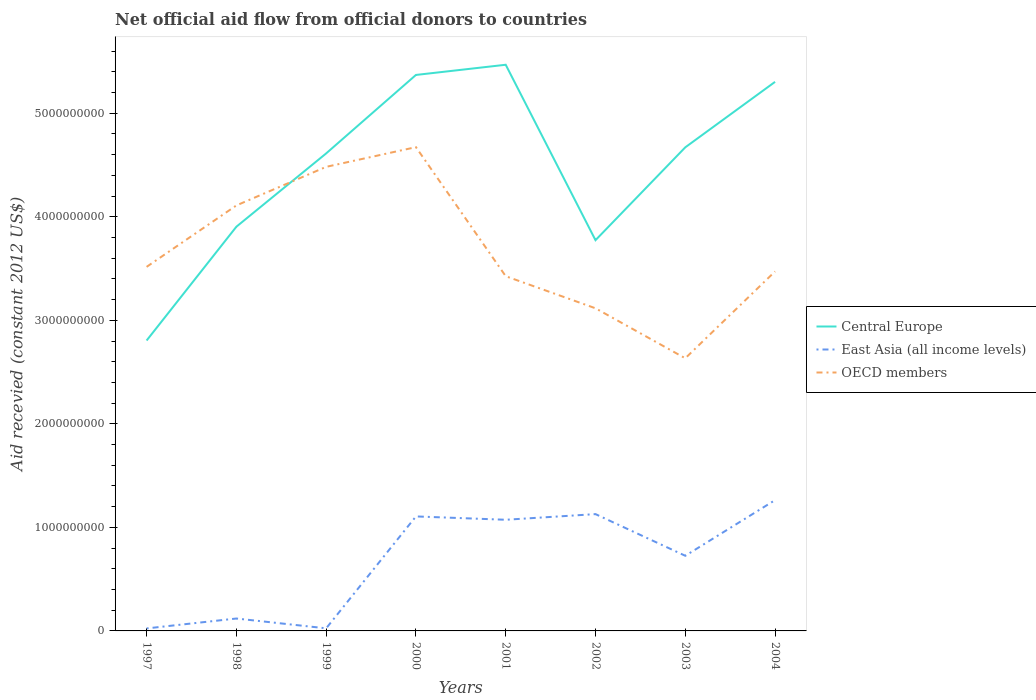Is the number of lines equal to the number of legend labels?
Your answer should be very brief. Yes. Across all years, what is the maximum total aid received in East Asia (all income levels)?
Provide a short and direct response. 2.41e+07. What is the total total aid received in East Asia (all income levels) in the graph?
Offer a very short reply. -1.90e+08. What is the difference between the highest and the second highest total aid received in East Asia (all income levels)?
Make the answer very short. 1.24e+09. Is the total aid received in Central Europe strictly greater than the total aid received in East Asia (all income levels) over the years?
Offer a very short reply. No. How many years are there in the graph?
Ensure brevity in your answer.  8. Does the graph contain any zero values?
Provide a succinct answer. No. How many legend labels are there?
Give a very brief answer. 3. What is the title of the graph?
Provide a succinct answer. Net official aid flow from official donors to countries. What is the label or title of the Y-axis?
Your response must be concise. Aid recevied (constant 2012 US$). What is the Aid recevied (constant 2012 US$) in Central Europe in 1997?
Ensure brevity in your answer.  2.81e+09. What is the Aid recevied (constant 2012 US$) in East Asia (all income levels) in 1997?
Your response must be concise. 2.41e+07. What is the Aid recevied (constant 2012 US$) of OECD members in 1997?
Offer a very short reply. 3.52e+09. What is the Aid recevied (constant 2012 US$) of Central Europe in 1998?
Your answer should be very brief. 3.90e+09. What is the Aid recevied (constant 2012 US$) of East Asia (all income levels) in 1998?
Make the answer very short. 1.20e+08. What is the Aid recevied (constant 2012 US$) of OECD members in 1998?
Offer a terse response. 4.11e+09. What is the Aid recevied (constant 2012 US$) of Central Europe in 1999?
Offer a terse response. 4.61e+09. What is the Aid recevied (constant 2012 US$) in East Asia (all income levels) in 1999?
Keep it short and to the point. 2.50e+07. What is the Aid recevied (constant 2012 US$) of OECD members in 1999?
Provide a short and direct response. 4.48e+09. What is the Aid recevied (constant 2012 US$) in Central Europe in 2000?
Keep it short and to the point. 5.37e+09. What is the Aid recevied (constant 2012 US$) of East Asia (all income levels) in 2000?
Offer a terse response. 1.11e+09. What is the Aid recevied (constant 2012 US$) of OECD members in 2000?
Give a very brief answer. 4.67e+09. What is the Aid recevied (constant 2012 US$) in Central Europe in 2001?
Make the answer very short. 5.47e+09. What is the Aid recevied (constant 2012 US$) of East Asia (all income levels) in 2001?
Your response must be concise. 1.07e+09. What is the Aid recevied (constant 2012 US$) of OECD members in 2001?
Ensure brevity in your answer.  3.43e+09. What is the Aid recevied (constant 2012 US$) in Central Europe in 2002?
Your answer should be compact. 3.77e+09. What is the Aid recevied (constant 2012 US$) of East Asia (all income levels) in 2002?
Your answer should be compact. 1.13e+09. What is the Aid recevied (constant 2012 US$) of OECD members in 2002?
Your response must be concise. 3.12e+09. What is the Aid recevied (constant 2012 US$) in Central Europe in 2003?
Ensure brevity in your answer.  4.67e+09. What is the Aid recevied (constant 2012 US$) in East Asia (all income levels) in 2003?
Your answer should be compact. 7.26e+08. What is the Aid recevied (constant 2012 US$) in OECD members in 2003?
Make the answer very short. 2.63e+09. What is the Aid recevied (constant 2012 US$) of Central Europe in 2004?
Your answer should be compact. 5.30e+09. What is the Aid recevied (constant 2012 US$) in East Asia (all income levels) in 2004?
Provide a short and direct response. 1.26e+09. What is the Aid recevied (constant 2012 US$) of OECD members in 2004?
Your answer should be very brief. 3.47e+09. Across all years, what is the maximum Aid recevied (constant 2012 US$) in Central Europe?
Give a very brief answer. 5.47e+09. Across all years, what is the maximum Aid recevied (constant 2012 US$) of East Asia (all income levels)?
Keep it short and to the point. 1.26e+09. Across all years, what is the maximum Aid recevied (constant 2012 US$) in OECD members?
Offer a very short reply. 4.67e+09. Across all years, what is the minimum Aid recevied (constant 2012 US$) in Central Europe?
Give a very brief answer. 2.81e+09. Across all years, what is the minimum Aid recevied (constant 2012 US$) of East Asia (all income levels)?
Provide a succinct answer. 2.41e+07. Across all years, what is the minimum Aid recevied (constant 2012 US$) in OECD members?
Your answer should be compact. 2.63e+09. What is the total Aid recevied (constant 2012 US$) of Central Europe in the graph?
Your answer should be very brief. 3.59e+1. What is the total Aid recevied (constant 2012 US$) of East Asia (all income levels) in the graph?
Your answer should be very brief. 5.47e+09. What is the total Aid recevied (constant 2012 US$) in OECD members in the graph?
Offer a very short reply. 2.94e+1. What is the difference between the Aid recevied (constant 2012 US$) of Central Europe in 1997 and that in 1998?
Provide a succinct answer. -1.10e+09. What is the difference between the Aid recevied (constant 2012 US$) in East Asia (all income levels) in 1997 and that in 1998?
Keep it short and to the point. -9.57e+07. What is the difference between the Aid recevied (constant 2012 US$) in OECD members in 1997 and that in 1998?
Provide a succinct answer. -5.93e+08. What is the difference between the Aid recevied (constant 2012 US$) in Central Europe in 1997 and that in 1999?
Your answer should be compact. -1.81e+09. What is the difference between the Aid recevied (constant 2012 US$) in East Asia (all income levels) in 1997 and that in 1999?
Offer a terse response. -9.50e+05. What is the difference between the Aid recevied (constant 2012 US$) of OECD members in 1997 and that in 1999?
Keep it short and to the point. -9.66e+08. What is the difference between the Aid recevied (constant 2012 US$) of Central Europe in 1997 and that in 2000?
Keep it short and to the point. -2.57e+09. What is the difference between the Aid recevied (constant 2012 US$) in East Asia (all income levels) in 1997 and that in 2000?
Ensure brevity in your answer.  -1.08e+09. What is the difference between the Aid recevied (constant 2012 US$) in OECD members in 1997 and that in 2000?
Give a very brief answer. -1.16e+09. What is the difference between the Aid recevied (constant 2012 US$) in Central Europe in 1997 and that in 2001?
Offer a terse response. -2.66e+09. What is the difference between the Aid recevied (constant 2012 US$) in East Asia (all income levels) in 1997 and that in 2001?
Give a very brief answer. -1.05e+09. What is the difference between the Aid recevied (constant 2012 US$) of OECD members in 1997 and that in 2001?
Ensure brevity in your answer.  9.02e+07. What is the difference between the Aid recevied (constant 2012 US$) in Central Europe in 1997 and that in 2002?
Give a very brief answer. -9.69e+08. What is the difference between the Aid recevied (constant 2012 US$) of East Asia (all income levels) in 1997 and that in 2002?
Give a very brief answer. -1.10e+09. What is the difference between the Aid recevied (constant 2012 US$) of OECD members in 1997 and that in 2002?
Your answer should be very brief. 4.00e+08. What is the difference between the Aid recevied (constant 2012 US$) in Central Europe in 1997 and that in 2003?
Give a very brief answer. -1.87e+09. What is the difference between the Aid recevied (constant 2012 US$) of East Asia (all income levels) in 1997 and that in 2003?
Make the answer very short. -7.02e+08. What is the difference between the Aid recevied (constant 2012 US$) in OECD members in 1997 and that in 2003?
Your answer should be compact. 8.83e+08. What is the difference between the Aid recevied (constant 2012 US$) of Central Europe in 1997 and that in 2004?
Offer a very short reply. -2.50e+09. What is the difference between the Aid recevied (constant 2012 US$) in East Asia (all income levels) in 1997 and that in 2004?
Give a very brief answer. -1.24e+09. What is the difference between the Aid recevied (constant 2012 US$) of OECD members in 1997 and that in 2004?
Provide a succinct answer. 4.42e+07. What is the difference between the Aid recevied (constant 2012 US$) in Central Europe in 1998 and that in 1999?
Your answer should be compact. -7.08e+08. What is the difference between the Aid recevied (constant 2012 US$) in East Asia (all income levels) in 1998 and that in 1999?
Offer a terse response. 9.48e+07. What is the difference between the Aid recevied (constant 2012 US$) of OECD members in 1998 and that in 1999?
Give a very brief answer. -3.73e+08. What is the difference between the Aid recevied (constant 2012 US$) in Central Europe in 1998 and that in 2000?
Provide a succinct answer. -1.47e+09. What is the difference between the Aid recevied (constant 2012 US$) in East Asia (all income levels) in 1998 and that in 2000?
Provide a succinct answer. -9.86e+08. What is the difference between the Aid recevied (constant 2012 US$) of OECD members in 1998 and that in 2000?
Ensure brevity in your answer.  -5.63e+08. What is the difference between the Aid recevied (constant 2012 US$) of Central Europe in 1998 and that in 2001?
Keep it short and to the point. -1.56e+09. What is the difference between the Aid recevied (constant 2012 US$) in East Asia (all income levels) in 1998 and that in 2001?
Keep it short and to the point. -9.54e+08. What is the difference between the Aid recevied (constant 2012 US$) in OECD members in 1998 and that in 2001?
Your response must be concise. 6.84e+08. What is the difference between the Aid recevied (constant 2012 US$) in Central Europe in 1998 and that in 2002?
Offer a very short reply. 1.30e+08. What is the difference between the Aid recevied (constant 2012 US$) of East Asia (all income levels) in 1998 and that in 2002?
Offer a very short reply. -1.01e+09. What is the difference between the Aid recevied (constant 2012 US$) of OECD members in 1998 and that in 2002?
Offer a terse response. 9.93e+08. What is the difference between the Aid recevied (constant 2012 US$) in Central Europe in 1998 and that in 2003?
Give a very brief answer. -7.67e+08. What is the difference between the Aid recevied (constant 2012 US$) of East Asia (all income levels) in 1998 and that in 2003?
Provide a short and direct response. -6.06e+08. What is the difference between the Aid recevied (constant 2012 US$) in OECD members in 1998 and that in 2003?
Keep it short and to the point. 1.48e+09. What is the difference between the Aid recevied (constant 2012 US$) of Central Europe in 1998 and that in 2004?
Your answer should be compact. -1.40e+09. What is the difference between the Aid recevied (constant 2012 US$) in East Asia (all income levels) in 1998 and that in 2004?
Provide a short and direct response. -1.14e+09. What is the difference between the Aid recevied (constant 2012 US$) of OECD members in 1998 and that in 2004?
Offer a very short reply. 6.38e+08. What is the difference between the Aid recevied (constant 2012 US$) in Central Europe in 1999 and that in 2000?
Provide a short and direct response. -7.58e+08. What is the difference between the Aid recevied (constant 2012 US$) of East Asia (all income levels) in 1999 and that in 2000?
Your response must be concise. -1.08e+09. What is the difference between the Aid recevied (constant 2012 US$) in OECD members in 1999 and that in 2000?
Your answer should be very brief. -1.90e+08. What is the difference between the Aid recevied (constant 2012 US$) in Central Europe in 1999 and that in 2001?
Make the answer very short. -8.56e+08. What is the difference between the Aid recevied (constant 2012 US$) of East Asia (all income levels) in 1999 and that in 2001?
Keep it short and to the point. -1.05e+09. What is the difference between the Aid recevied (constant 2012 US$) of OECD members in 1999 and that in 2001?
Offer a very short reply. 1.06e+09. What is the difference between the Aid recevied (constant 2012 US$) of Central Europe in 1999 and that in 2002?
Make the answer very short. 8.38e+08. What is the difference between the Aid recevied (constant 2012 US$) of East Asia (all income levels) in 1999 and that in 2002?
Give a very brief answer. -1.10e+09. What is the difference between the Aid recevied (constant 2012 US$) of OECD members in 1999 and that in 2002?
Provide a succinct answer. 1.37e+09. What is the difference between the Aid recevied (constant 2012 US$) of Central Europe in 1999 and that in 2003?
Your response must be concise. -5.87e+07. What is the difference between the Aid recevied (constant 2012 US$) in East Asia (all income levels) in 1999 and that in 2003?
Give a very brief answer. -7.01e+08. What is the difference between the Aid recevied (constant 2012 US$) of OECD members in 1999 and that in 2003?
Make the answer very short. 1.85e+09. What is the difference between the Aid recevied (constant 2012 US$) in Central Europe in 1999 and that in 2004?
Provide a short and direct response. -6.91e+08. What is the difference between the Aid recevied (constant 2012 US$) in East Asia (all income levels) in 1999 and that in 2004?
Provide a short and direct response. -1.24e+09. What is the difference between the Aid recevied (constant 2012 US$) in OECD members in 1999 and that in 2004?
Provide a succinct answer. 1.01e+09. What is the difference between the Aid recevied (constant 2012 US$) in Central Europe in 2000 and that in 2001?
Your answer should be very brief. -9.83e+07. What is the difference between the Aid recevied (constant 2012 US$) in East Asia (all income levels) in 2000 and that in 2001?
Make the answer very short. 3.23e+07. What is the difference between the Aid recevied (constant 2012 US$) of OECD members in 2000 and that in 2001?
Ensure brevity in your answer.  1.25e+09. What is the difference between the Aid recevied (constant 2012 US$) in Central Europe in 2000 and that in 2002?
Provide a short and direct response. 1.60e+09. What is the difference between the Aid recevied (constant 2012 US$) in East Asia (all income levels) in 2000 and that in 2002?
Your answer should be compact. -2.23e+07. What is the difference between the Aid recevied (constant 2012 US$) of OECD members in 2000 and that in 2002?
Make the answer very short. 1.56e+09. What is the difference between the Aid recevied (constant 2012 US$) in Central Europe in 2000 and that in 2003?
Provide a succinct answer. 6.99e+08. What is the difference between the Aid recevied (constant 2012 US$) of East Asia (all income levels) in 2000 and that in 2003?
Keep it short and to the point. 3.80e+08. What is the difference between the Aid recevied (constant 2012 US$) in OECD members in 2000 and that in 2003?
Give a very brief answer. 2.04e+09. What is the difference between the Aid recevied (constant 2012 US$) of Central Europe in 2000 and that in 2004?
Your answer should be compact. 6.68e+07. What is the difference between the Aid recevied (constant 2012 US$) of East Asia (all income levels) in 2000 and that in 2004?
Your answer should be very brief. -1.57e+08. What is the difference between the Aid recevied (constant 2012 US$) in OECD members in 2000 and that in 2004?
Your answer should be very brief. 1.20e+09. What is the difference between the Aid recevied (constant 2012 US$) of Central Europe in 2001 and that in 2002?
Your response must be concise. 1.69e+09. What is the difference between the Aid recevied (constant 2012 US$) of East Asia (all income levels) in 2001 and that in 2002?
Give a very brief answer. -5.46e+07. What is the difference between the Aid recevied (constant 2012 US$) in OECD members in 2001 and that in 2002?
Provide a succinct answer. 3.10e+08. What is the difference between the Aid recevied (constant 2012 US$) of Central Europe in 2001 and that in 2003?
Ensure brevity in your answer.  7.98e+08. What is the difference between the Aid recevied (constant 2012 US$) of East Asia (all income levels) in 2001 and that in 2003?
Provide a succinct answer. 3.48e+08. What is the difference between the Aid recevied (constant 2012 US$) in OECD members in 2001 and that in 2003?
Provide a succinct answer. 7.93e+08. What is the difference between the Aid recevied (constant 2012 US$) in Central Europe in 2001 and that in 2004?
Offer a terse response. 1.65e+08. What is the difference between the Aid recevied (constant 2012 US$) in East Asia (all income levels) in 2001 and that in 2004?
Provide a succinct answer. -1.90e+08. What is the difference between the Aid recevied (constant 2012 US$) in OECD members in 2001 and that in 2004?
Provide a short and direct response. -4.60e+07. What is the difference between the Aid recevied (constant 2012 US$) in Central Europe in 2002 and that in 2003?
Your answer should be compact. -8.97e+08. What is the difference between the Aid recevied (constant 2012 US$) in East Asia (all income levels) in 2002 and that in 2003?
Provide a succinct answer. 4.02e+08. What is the difference between the Aid recevied (constant 2012 US$) in OECD members in 2002 and that in 2003?
Offer a terse response. 4.83e+08. What is the difference between the Aid recevied (constant 2012 US$) of Central Europe in 2002 and that in 2004?
Your answer should be compact. -1.53e+09. What is the difference between the Aid recevied (constant 2012 US$) of East Asia (all income levels) in 2002 and that in 2004?
Offer a very short reply. -1.35e+08. What is the difference between the Aid recevied (constant 2012 US$) in OECD members in 2002 and that in 2004?
Give a very brief answer. -3.56e+08. What is the difference between the Aid recevied (constant 2012 US$) of Central Europe in 2003 and that in 2004?
Make the answer very short. -6.32e+08. What is the difference between the Aid recevied (constant 2012 US$) of East Asia (all income levels) in 2003 and that in 2004?
Offer a terse response. -5.38e+08. What is the difference between the Aid recevied (constant 2012 US$) of OECD members in 2003 and that in 2004?
Give a very brief answer. -8.39e+08. What is the difference between the Aid recevied (constant 2012 US$) in Central Europe in 1997 and the Aid recevied (constant 2012 US$) in East Asia (all income levels) in 1998?
Your answer should be very brief. 2.69e+09. What is the difference between the Aid recevied (constant 2012 US$) in Central Europe in 1997 and the Aid recevied (constant 2012 US$) in OECD members in 1998?
Offer a very short reply. -1.30e+09. What is the difference between the Aid recevied (constant 2012 US$) in East Asia (all income levels) in 1997 and the Aid recevied (constant 2012 US$) in OECD members in 1998?
Your answer should be very brief. -4.09e+09. What is the difference between the Aid recevied (constant 2012 US$) of Central Europe in 1997 and the Aid recevied (constant 2012 US$) of East Asia (all income levels) in 1999?
Keep it short and to the point. 2.78e+09. What is the difference between the Aid recevied (constant 2012 US$) in Central Europe in 1997 and the Aid recevied (constant 2012 US$) in OECD members in 1999?
Your answer should be compact. -1.68e+09. What is the difference between the Aid recevied (constant 2012 US$) in East Asia (all income levels) in 1997 and the Aid recevied (constant 2012 US$) in OECD members in 1999?
Offer a very short reply. -4.46e+09. What is the difference between the Aid recevied (constant 2012 US$) in Central Europe in 1997 and the Aid recevied (constant 2012 US$) in East Asia (all income levels) in 2000?
Your response must be concise. 1.70e+09. What is the difference between the Aid recevied (constant 2012 US$) in Central Europe in 1997 and the Aid recevied (constant 2012 US$) in OECD members in 2000?
Your answer should be compact. -1.87e+09. What is the difference between the Aid recevied (constant 2012 US$) in East Asia (all income levels) in 1997 and the Aid recevied (constant 2012 US$) in OECD members in 2000?
Give a very brief answer. -4.65e+09. What is the difference between the Aid recevied (constant 2012 US$) in Central Europe in 1997 and the Aid recevied (constant 2012 US$) in East Asia (all income levels) in 2001?
Provide a succinct answer. 1.73e+09. What is the difference between the Aid recevied (constant 2012 US$) in Central Europe in 1997 and the Aid recevied (constant 2012 US$) in OECD members in 2001?
Make the answer very short. -6.21e+08. What is the difference between the Aid recevied (constant 2012 US$) in East Asia (all income levels) in 1997 and the Aid recevied (constant 2012 US$) in OECD members in 2001?
Your answer should be compact. -3.40e+09. What is the difference between the Aid recevied (constant 2012 US$) of Central Europe in 1997 and the Aid recevied (constant 2012 US$) of East Asia (all income levels) in 2002?
Ensure brevity in your answer.  1.68e+09. What is the difference between the Aid recevied (constant 2012 US$) of Central Europe in 1997 and the Aid recevied (constant 2012 US$) of OECD members in 2002?
Give a very brief answer. -3.11e+08. What is the difference between the Aid recevied (constant 2012 US$) of East Asia (all income levels) in 1997 and the Aid recevied (constant 2012 US$) of OECD members in 2002?
Keep it short and to the point. -3.09e+09. What is the difference between the Aid recevied (constant 2012 US$) of Central Europe in 1997 and the Aid recevied (constant 2012 US$) of East Asia (all income levels) in 2003?
Provide a short and direct response. 2.08e+09. What is the difference between the Aid recevied (constant 2012 US$) in Central Europe in 1997 and the Aid recevied (constant 2012 US$) in OECD members in 2003?
Give a very brief answer. 1.72e+08. What is the difference between the Aid recevied (constant 2012 US$) in East Asia (all income levels) in 1997 and the Aid recevied (constant 2012 US$) in OECD members in 2003?
Keep it short and to the point. -2.61e+09. What is the difference between the Aid recevied (constant 2012 US$) in Central Europe in 1997 and the Aid recevied (constant 2012 US$) in East Asia (all income levels) in 2004?
Provide a short and direct response. 1.54e+09. What is the difference between the Aid recevied (constant 2012 US$) of Central Europe in 1997 and the Aid recevied (constant 2012 US$) of OECD members in 2004?
Offer a terse response. -6.67e+08. What is the difference between the Aid recevied (constant 2012 US$) of East Asia (all income levels) in 1997 and the Aid recevied (constant 2012 US$) of OECD members in 2004?
Provide a short and direct response. -3.45e+09. What is the difference between the Aid recevied (constant 2012 US$) in Central Europe in 1998 and the Aid recevied (constant 2012 US$) in East Asia (all income levels) in 1999?
Keep it short and to the point. 3.88e+09. What is the difference between the Aid recevied (constant 2012 US$) of Central Europe in 1998 and the Aid recevied (constant 2012 US$) of OECD members in 1999?
Provide a short and direct response. -5.78e+08. What is the difference between the Aid recevied (constant 2012 US$) of East Asia (all income levels) in 1998 and the Aid recevied (constant 2012 US$) of OECD members in 1999?
Provide a short and direct response. -4.36e+09. What is the difference between the Aid recevied (constant 2012 US$) of Central Europe in 1998 and the Aid recevied (constant 2012 US$) of East Asia (all income levels) in 2000?
Offer a terse response. 2.80e+09. What is the difference between the Aid recevied (constant 2012 US$) of Central Europe in 1998 and the Aid recevied (constant 2012 US$) of OECD members in 2000?
Give a very brief answer. -7.68e+08. What is the difference between the Aid recevied (constant 2012 US$) of East Asia (all income levels) in 1998 and the Aid recevied (constant 2012 US$) of OECD members in 2000?
Ensure brevity in your answer.  -4.55e+09. What is the difference between the Aid recevied (constant 2012 US$) of Central Europe in 1998 and the Aid recevied (constant 2012 US$) of East Asia (all income levels) in 2001?
Offer a very short reply. 2.83e+09. What is the difference between the Aid recevied (constant 2012 US$) of Central Europe in 1998 and the Aid recevied (constant 2012 US$) of OECD members in 2001?
Provide a short and direct response. 4.78e+08. What is the difference between the Aid recevied (constant 2012 US$) of East Asia (all income levels) in 1998 and the Aid recevied (constant 2012 US$) of OECD members in 2001?
Make the answer very short. -3.31e+09. What is the difference between the Aid recevied (constant 2012 US$) in Central Europe in 1998 and the Aid recevied (constant 2012 US$) in East Asia (all income levels) in 2002?
Make the answer very short. 2.78e+09. What is the difference between the Aid recevied (constant 2012 US$) in Central Europe in 1998 and the Aid recevied (constant 2012 US$) in OECD members in 2002?
Provide a succinct answer. 7.88e+08. What is the difference between the Aid recevied (constant 2012 US$) in East Asia (all income levels) in 1998 and the Aid recevied (constant 2012 US$) in OECD members in 2002?
Make the answer very short. -3.00e+09. What is the difference between the Aid recevied (constant 2012 US$) in Central Europe in 1998 and the Aid recevied (constant 2012 US$) in East Asia (all income levels) in 2003?
Ensure brevity in your answer.  3.18e+09. What is the difference between the Aid recevied (constant 2012 US$) of Central Europe in 1998 and the Aid recevied (constant 2012 US$) of OECD members in 2003?
Make the answer very short. 1.27e+09. What is the difference between the Aid recevied (constant 2012 US$) of East Asia (all income levels) in 1998 and the Aid recevied (constant 2012 US$) of OECD members in 2003?
Keep it short and to the point. -2.51e+09. What is the difference between the Aid recevied (constant 2012 US$) of Central Europe in 1998 and the Aid recevied (constant 2012 US$) of East Asia (all income levels) in 2004?
Provide a short and direct response. 2.64e+09. What is the difference between the Aid recevied (constant 2012 US$) of Central Europe in 1998 and the Aid recevied (constant 2012 US$) of OECD members in 2004?
Ensure brevity in your answer.  4.32e+08. What is the difference between the Aid recevied (constant 2012 US$) in East Asia (all income levels) in 1998 and the Aid recevied (constant 2012 US$) in OECD members in 2004?
Provide a succinct answer. -3.35e+09. What is the difference between the Aid recevied (constant 2012 US$) of Central Europe in 1999 and the Aid recevied (constant 2012 US$) of East Asia (all income levels) in 2000?
Your answer should be very brief. 3.51e+09. What is the difference between the Aid recevied (constant 2012 US$) in Central Europe in 1999 and the Aid recevied (constant 2012 US$) in OECD members in 2000?
Provide a succinct answer. -6.05e+07. What is the difference between the Aid recevied (constant 2012 US$) of East Asia (all income levels) in 1999 and the Aid recevied (constant 2012 US$) of OECD members in 2000?
Ensure brevity in your answer.  -4.65e+09. What is the difference between the Aid recevied (constant 2012 US$) in Central Europe in 1999 and the Aid recevied (constant 2012 US$) in East Asia (all income levels) in 2001?
Make the answer very short. 3.54e+09. What is the difference between the Aid recevied (constant 2012 US$) in Central Europe in 1999 and the Aid recevied (constant 2012 US$) in OECD members in 2001?
Your response must be concise. 1.19e+09. What is the difference between the Aid recevied (constant 2012 US$) in East Asia (all income levels) in 1999 and the Aid recevied (constant 2012 US$) in OECD members in 2001?
Your response must be concise. -3.40e+09. What is the difference between the Aid recevied (constant 2012 US$) in Central Europe in 1999 and the Aid recevied (constant 2012 US$) in East Asia (all income levels) in 2002?
Your answer should be very brief. 3.48e+09. What is the difference between the Aid recevied (constant 2012 US$) of Central Europe in 1999 and the Aid recevied (constant 2012 US$) of OECD members in 2002?
Ensure brevity in your answer.  1.50e+09. What is the difference between the Aid recevied (constant 2012 US$) in East Asia (all income levels) in 1999 and the Aid recevied (constant 2012 US$) in OECD members in 2002?
Give a very brief answer. -3.09e+09. What is the difference between the Aid recevied (constant 2012 US$) of Central Europe in 1999 and the Aid recevied (constant 2012 US$) of East Asia (all income levels) in 2003?
Make the answer very short. 3.89e+09. What is the difference between the Aid recevied (constant 2012 US$) of Central Europe in 1999 and the Aid recevied (constant 2012 US$) of OECD members in 2003?
Offer a terse response. 1.98e+09. What is the difference between the Aid recevied (constant 2012 US$) of East Asia (all income levels) in 1999 and the Aid recevied (constant 2012 US$) of OECD members in 2003?
Give a very brief answer. -2.61e+09. What is the difference between the Aid recevied (constant 2012 US$) of Central Europe in 1999 and the Aid recevied (constant 2012 US$) of East Asia (all income levels) in 2004?
Your answer should be very brief. 3.35e+09. What is the difference between the Aid recevied (constant 2012 US$) in Central Europe in 1999 and the Aid recevied (constant 2012 US$) in OECD members in 2004?
Offer a very short reply. 1.14e+09. What is the difference between the Aid recevied (constant 2012 US$) of East Asia (all income levels) in 1999 and the Aid recevied (constant 2012 US$) of OECD members in 2004?
Your answer should be compact. -3.45e+09. What is the difference between the Aid recevied (constant 2012 US$) in Central Europe in 2000 and the Aid recevied (constant 2012 US$) in East Asia (all income levels) in 2001?
Give a very brief answer. 4.30e+09. What is the difference between the Aid recevied (constant 2012 US$) of Central Europe in 2000 and the Aid recevied (constant 2012 US$) of OECD members in 2001?
Offer a very short reply. 1.94e+09. What is the difference between the Aid recevied (constant 2012 US$) in East Asia (all income levels) in 2000 and the Aid recevied (constant 2012 US$) in OECD members in 2001?
Make the answer very short. -2.32e+09. What is the difference between the Aid recevied (constant 2012 US$) of Central Europe in 2000 and the Aid recevied (constant 2012 US$) of East Asia (all income levels) in 2002?
Your answer should be compact. 4.24e+09. What is the difference between the Aid recevied (constant 2012 US$) of Central Europe in 2000 and the Aid recevied (constant 2012 US$) of OECD members in 2002?
Provide a short and direct response. 2.25e+09. What is the difference between the Aid recevied (constant 2012 US$) in East Asia (all income levels) in 2000 and the Aid recevied (constant 2012 US$) in OECD members in 2002?
Provide a short and direct response. -2.01e+09. What is the difference between the Aid recevied (constant 2012 US$) of Central Europe in 2000 and the Aid recevied (constant 2012 US$) of East Asia (all income levels) in 2003?
Your response must be concise. 4.64e+09. What is the difference between the Aid recevied (constant 2012 US$) in Central Europe in 2000 and the Aid recevied (constant 2012 US$) in OECD members in 2003?
Your response must be concise. 2.74e+09. What is the difference between the Aid recevied (constant 2012 US$) of East Asia (all income levels) in 2000 and the Aid recevied (constant 2012 US$) of OECD members in 2003?
Give a very brief answer. -1.53e+09. What is the difference between the Aid recevied (constant 2012 US$) of Central Europe in 2000 and the Aid recevied (constant 2012 US$) of East Asia (all income levels) in 2004?
Your answer should be compact. 4.11e+09. What is the difference between the Aid recevied (constant 2012 US$) in Central Europe in 2000 and the Aid recevied (constant 2012 US$) in OECD members in 2004?
Your answer should be very brief. 1.90e+09. What is the difference between the Aid recevied (constant 2012 US$) in East Asia (all income levels) in 2000 and the Aid recevied (constant 2012 US$) in OECD members in 2004?
Your response must be concise. -2.37e+09. What is the difference between the Aid recevied (constant 2012 US$) of Central Europe in 2001 and the Aid recevied (constant 2012 US$) of East Asia (all income levels) in 2002?
Offer a terse response. 4.34e+09. What is the difference between the Aid recevied (constant 2012 US$) in Central Europe in 2001 and the Aid recevied (constant 2012 US$) in OECD members in 2002?
Keep it short and to the point. 2.35e+09. What is the difference between the Aid recevied (constant 2012 US$) of East Asia (all income levels) in 2001 and the Aid recevied (constant 2012 US$) of OECD members in 2002?
Keep it short and to the point. -2.04e+09. What is the difference between the Aid recevied (constant 2012 US$) in Central Europe in 2001 and the Aid recevied (constant 2012 US$) in East Asia (all income levels) in 2003?
Your answer should be compact. 4.74e+09. What is the difference between the Aid recevied (constant 2012 US$) of Central Europe in 2001 and the Aid recevied (constant 2012 US$) of OECD members in 2003?
Your answer should be very brief. 2.84e+09. What is the difference between the Aid recevied (constant 2012 US$) of East Asia (all income levels) in 2001 and the Aid recevied (constant 2012 US$) of OECD members in 2003?
Keep it short and to the point. -1.56e+09. What is the difference between the Aid recevied (constant 2012 US$) of Central Europe in 2001 and the Aid recevied (constant 2012 US$) of East Asia (all income levels) in 2004?
Make the answer very short. 4.21e+09. What is the difference between the Aid recevied (constant 2012 US$) of Central Europe in 2001 and the Aid recevied (constant 2012 US$) of OECD members in 2004?
Give a very brief answer. 2.00e+09. What is the difference between the Aid recevied (constant 2012 US$) in East Asia (all income levels) in 2001 and the Aid recevied (constant 2012 US$) in OECD members in 2004?
Your answer should be very brief. -2.40e+09. What is the difference between the Aid recevied (constant 2012 US$) of Central Europe in 2002 and the Aid recevied (constant 2012 US$) of East Asia (all income levels) in 2003?
Your answer should be compact. 3.05e+09. What is the difference between the Aid recevied (constant 2012 US$) of Central Europe in 2002 and the Aid recevied (constant 2012 US$) of OECD members in 2003?
Offer a very short reply. 1.14e+09. What is the difference between the Aid recevied (constant 2012 US$) in East Asia (all income levels) in 2002 and the Aid recevied (constant 2012 US$) in OECD members in 2003?
Make the answer very short. -1.51e+09. What is the difference between the Aid recevied (constant 2012 US$) in Central Europe in 2002 and the Aid recevied (constant 2012 US$) in East Asia (all income levels) in 2004?
Make the answer very short. 2.51e+09. What is the difference between the Aid recevied (constant 2012 US$) in Central Europe in 2002 and the Aid recevied (constant 2012 US$) in OECD members in 2004?
Ensure brevity in your answer.  3.02e+08. What is the difference between the Aid recevied (constant 2012 US$) of East Asia (all income levels) in 2002 and the Aid recevied (constant 2012 US$) of OECD members in 2004?
Give a very brief answer. -2.34e+09. What is the difference between the Aid recevied (constant 2012 US$) of Central Europe in 2003 and the Aid recevied (constant 2012 US$) of East Asia (all income levels) in 2004?
Keep it short and to the point. 3.41e+09. What is the difference between the Aid recevied (constant 2012 US$) in Central Europe in 2003 and the Aid recevied (constant 2012 US$) in OECD members in 2004?
Ensure brevity in your answer.  1.20e+09. What is the difference between the Aid recevied (constant 2012 US$) in East Asia (all income levels) in 2003 and the Aid recevied (constant 2012 US$) in OECD members in 2004?
Your answer should be very brief. -2.75e+09. What is the average Aid recevied (constant 2012 US$) of Central Europe per year?
Provide a succinct answer. 4.49e+09. What is the average Aid recevied (constant 2012 US$) in East Asia (all income levels) per year?
Keep it short and to the point. 6.83e+08. What is the average Aid recevied (constant 2012 US$) of OECD members per year?
Keep it short and to the point. 3.68e+09. In the year 1997, what is the difference between the Aid recevied (constant 2012 US$) of Central Europe and Aid recevied (constant 2012 US$) of East Asia (all income levels)?
Your answer should be very brief. 2.78e+09. In the year 1997, what is the difference between the Aid recevied (constant 2012 US$) of Central Europe and Aid recevied (constant 2012 US$) of OECD members?
Provide a short and direct response. -7.11e+08. In the year 1997, what is the difference between the Aid recevied (constant 2012 US$) of East Asia (all income levels) and Aid recevied (constant 2012 US$) of OECD members?
Offer a terse response. -3.49e+09. In the year 1998, what is the difference between the Aid recevied (constant 2012 US$) of Central Europe and Aid recevied (constant 2012 US$) of East Asia (all income levels)?
Your response must be concise. 3.78e+09. In the year 1998, what is the difference between the Aid recevied (constant 2012 US$) of Central Europe and Aid recevied (constant 2012 US$) of OECD members?
Ensure brevity in your answer.  -2.05e+08. In the year 1998, what is the difference between the Aid recevied (constant 2012 US$) of East Asia (all income levels) and Aid recevied (constant 2012 US$) of OECD members?
Your answer should be compact. -3.99e+09. In the year 1999, what is the difference between the Aid recevied (constant 2012 US$) of Central Europe and Aid recevied (constant 2012 US$) of East Asia (all income levels)?
Keep it short and to the point. 4.59e+09. In the year 1999, what is the difference between the Aid recevied (constant 2012 US$) of Central Europe and Aid recevied (constant 2012 US$) of OECD members?
Your answer should be compact. 1.30e+08. In the year 1999, what is the difference between the Aid recevied (constant 2012 US$) in East Asia (all income levels) and Aid recevied (constant 2012 US$) in OECD members?
Offer a terse response. -4.46e+09. In the year 2000, what is the difference between the Aid recevied (constant 2012 US$) of Central Europe and Aid recevied (constant 2012 US$) of East Asia (all income levels)?
Ensure brevity in your answer.  4.26e+09. In the year 2000, what is the difference between the Aid recevied (constant 2012 US$) in Central Europe and Aid recevied (constant 2012 US$) in OECD members?
Offer a very short reply. 6.97e+08. In the year 2000, what is the difference between the Aid recevied (constant 2012 US$) in East Asia (all income levels) and Aid recevied (constant 2012 US$) in OECD members?
Offer a very short reply. -3.57e+09. In the year 2001, what is the difference between the Aid recevied (constant 2012 US$) in Central Europe and Aid recevied (constant 2012 US$) in East Asia (all income levels)?
Provide a succinct answer. 4.39e+09. In the year 2001, what is the difference between the Aid recevied (constant 2012 US$) of Central Europe and Aid recevied (constant 2012 US$) of OECD members?
Your answer should be compact. 2.04e+09. In the year 2001, what is the difference between the Aid recevied (constant 2012 US$) of East Asia (all income levels) and Aid recevied (constant 2012 US$) of OECD members?
Keep it short and to the point. -2.35e+09. In the year 2002, what is the difference between the Aid recevied (constant 2012 US$) in Central Europe and Aid recevied (constant 2012 US$) in East Asia (all income levels)?
Offer a very short reply. 2.65e+09. In the year 2002, what is the difference between the Aid recevied (constant 2012 US$) of Central Europe and Aid recevied (constant 2012 US$) of OECD members?
Give a very brief answer. 6.58e+08. In the year 2002, what is the difference between the Aid recevied (constant 2012 US$) of East Asia (all income levels) and Aid recevied (constant 2012 US$) of OECD members?
Provide a short and direct response. -1.99e+09. In the year 2003, what is the difference between the Aid recevied (constant 2012 US$) of Central Europe and Aid recevied (constant 2012 US$) of East Asia (all income levels)?
Your response must be concise. 3.95e+09. In the year 2003, what is the difference between the Aid recevied (constant 2012 US$) of Central Europe and Aid recevied (constant 2012 US$) of OECD members?
Keep it short and to the point. 2.04e+09. In the year 2003, what is the difference between the Aid recevied (constant 2012 US$) in East Asia (all income levels) and Aid recevied (constant 2012 US$) in OECD members?
Ensure brevity in your answer.  -1.91e+09. In the year 2004, what is the difference between the Aid recevied (constant 2012 US$) of Central Europe and Aid recevied (constant 2012 US$) of East Asia (all income levels)?
Make the answer very short. 4.04e+09. In the year 2004, what is the difference between the Aid recevied (constant 2012 US$) of Central Europe and Aid recevied (constant 2012 US$) of OECD members?
Your answer should be compact. 1.83e+09. In the year 2004, what is the difference between the Aid recevied (constant 2012 US$) in East Asia (all income levels) and Aid recevied (constant 2012 US$) in OECD members?
Ensure brevity in your answer.  -2.21e+09. What is the ratio of the Aid recevied (constant 2012 US$) of Central Europe in 1997 to that in 1998?
Provide a short and direct response. 0.72. What is the ratio of the Aid recevied (constant 2012 US$) of East Asia (all income levels) in 1997 to that in 1998?
Offer a terse response. 0.2. What is the ratio of the Aid recevied (constant 2012 US$) in OECD members in 1997 to that in 1998?
Make the answer very short. 0.86. What is the ratio of the Aid recevied (constant 2012 US$) of Central Europe in 1997 to that in 1999?
Offer a very short reply. 0.61. What is the ratio of the Aid recevied (constant 2012 US$) in OECD members in 1997 to that in 1999?
Provide a short and direct response. 0.78. What is the ratio of the Aid recevied (constant 2012 US$) in Central Europe in 1997 to that in 2000?
Provide a short and direct response. 0.52. What is the ratio of the Aid recevied (constant 2012 US$) of East Asia (all income levels) in 1997 to that in 2000?
Offer a very short reply. 0.02. What is the ratio of the Aid recevied (constant 2012 US$) of OECD members in 1997 to that in 2000?
Ensure brevity in your answer.  0.75. What is the ratio of the Aid recevied (constant 2012 US$) in Central Europe in 1997 to that in 2001?
Your answer should be compact. 0.51. What is the ratio of the Aid recevied (constant 2012 US$) in East Asia (all income levels) in 1997 to that in 2001?
Make the answer very short. 0.02. What is the ratio of the Aid recevied (constant 2012 US$) of OECD members in 1997 to that in 2001?
Ensure brevity in your answer.  1.03. What is the ratio of the Aid recevied (constant 2012 US$) in Central Europe in 1997 to that in 2002?
Your response must be concise. 0.74. What is the ratio of the Aid recevied (constant 2012 US$) of East Asia (all income levels) in 1997 to that in 2002?
Your answer should be very brief. 0.02. What is the ratio of the Aid recevied (constant 2012 US$) of OECD members in 1997 to that in 2002?
Make the answer very short. 1.13. What is the ratio of the Aid recevied (constant 2012 US$) in Central Europe in 1997 to that in 2003?
Offer a terse response. 0.6. What is the ratio of the Aid recevied (constant 2012 US$) in East Asia (all income levels) in 1997 to that in 2003?
Keep it short and to the point. 0.03. What is the ratio of the Aid recevied (constant 2012 US$) in OECD members in 1997 to that in 2003?
Make the answer very short. 1.34. What is the ratio of the Aid recevied (constant 2012 US$) of Central Europe in 1997 to that in 2004?
Make the answer very short. 0.53. What is the ratio of the Aid recevied (constant 2012 US$) in East Asia (all income levels) in 1997 to that in 2004?
Your answer should be very brief. 0.02. What is the ratio of the Aid recevied (constant 2012 US$) in OECD members in 1997 to that in 2004?
Give a very brief answer. 1.01. What is the ratio of the Aid recevied (constant 2012 US$) in Central Europe in 1998 to that in 1999?
Provide a short and direct response. 0.85. What is the ratio of the Aid recevied (constant 2012 US$) of East Asia (all income levels) in 1998 to that in 1999?
Your answer should be compact. 4.79. What is the ratio of the Aid recevied (constant 2012 US$) in OECD members in 1998 to that in 1999?
Provide a short and direct response. 0.92. What is the ratio of the Aid recevied (constant 2012 US$) in Central Europe in 1998 to that in 2000?
Your answer should be very brief. 0.73. What is the ratio of the Aid recevied (constant 2012 US$) in East Asia (all income levels) in 1998 to that in 2000?
Keep it short and to the point. 0.11. What is the ratio of the Aid recevied (constant 2012 US$) in OECD members in 1998 to that in 2000?
Your answer should be very brief. 0.88. What is the ratio of the Aid recevied (constant 2012 US$) of Central Europe in 1998 to that in 2001?
Keep it short and to the point. 0.71. What is the ratio of the Aid recevied (constant 2012 US$) of East Asia (all income levels) in 1998 to that in 2001?
Offer a terse response. 0.11. What is the ratio of the Aid recevied (constant 2012 US$) of OECD members in 1998 to that in 2001?
Provide a short and direct response. 1.2. What is the ratio of the Aid recevied (constant 2012 US$) of Central Europe in 1998 to that in 2002?
Provide a short and direct response. 1.03. What is the ratio of the Aid recevied (constant 2012 US$) of East Asia (all income levels) in 1998 to that in 2002?
Your answer should be very brief. 0.11. What is the ratio of the Aid recevied (constant 2012 US$) in OECD members in 1998 to that in 2002?
Give a very brief answer. 1.32. What is the ratio of the Aid recevied (constant 2012 US$) of Central Europe in 1998 to that in 2003?
Your response must be concise. 0.84. What is the ratio of the Aid recevied (constant 2012 US$) in East Asia (all income levels) in 1998 to that in 2003?
Make the answer very short. 0.17. What is the ratio of the Aid recevied (constant 2012 US$) in OECD members in 1998 to that in 2003?
Offer a very short reply. 1.56. What is the ratio of the Aid recevied (constant 2012 US$) of Central Europe in 1998 to that in 2004?
Your answer should be compact. 0.74. What is the ratio of the Aid recevied (constant 2012 US$) of East Asia (all income levels) in 1998 to that in 2004?
Your response must be concise. 0.09. What is the ratio of the Aid recevied (constant 2012 US$) of OECD members in 1998 to that in 2004?
Your answer should be compact. 1.18. What is the ratio of the Aid recevied (constant 2012 US$) of Central Europe in 1999 to that in 2000?
Your answer should be very brief. 0.86. What is the ratio of the Aid recevied (constant 2012 US$) in East Asia (all income levels) in 1999 to that in 2000?
Your answer should be very brief. 0.02. What is the ratio of the Aid recevied (constant 2012 US$) of OECD members in 1999 to that in 2000?
Ensure brevity in your answer.  0.96. What is the ratio of the Aid recevied (constant 2012 US$) in Central Europe in 1999 to that in 2001?
Provide a short and direct response. 0.84. What is the ratio of the Aid recevied (constant 2012 US$) in East Asia (all income levels) in 1999 to that in 2001?
Give a very brief answer. 0.02. What is the ratio of the Aid recevied (constant 2012 US$) of OECD members in 1999 to that in 2001?
Ensure brevity in your answer.  1.31. What is the ratio of the Aid recevied (constant 2012 US$) in Central Europe in 1999 to that in 2002?
Ensure brevity in your answer.  1.22. What is the ratio of the Aid recevied (constant 2012 US$) in East Asia (all income levels) in 1999 to that in 2002?
Provide a succinct answer. 0.02. What is the ratio of the Aid recevied (constant 2012 US$) in OECD members in 1999 to that in 2002?
Offer a terse response. 1.44. What is the ratio of the Aid recevied (constant 2012 US$) in Central Europe in 1999 to that in 2003?
Your answer should be very brief. 0.99. What is the ratio of the Aid recevied (constant 2012 US$) in East Asia (all income levels) in 1999 to that in 2003?
Provide a short and direct response. 0.03. What is the ratio of the Aid recevied (constant 2012 US$) of OECD members in 1999 to that in 2003?
Give a very brief answer. 1.7. What is the ratio of the Aid recevied (constant 2012 US$) in Central Europe in 1999 to that in 2004?
Your response must be concise. 0.87. What is the ratio of the Aid recevied (constant 2012 US$) of East Asia (all income levels) in 1999 to that in 2004?
Give a very brief answer. 0.02. What is the ratio of the Aid recevied (constant 2012 US$) in OECD members in 1999 to that in 2004?
Your answer should be very brief. 1.29. What is the ratio of the Aid recevied (constant 2012 US$) in Central Europe in 2000 to that in 2001?
Give a very brief answer. 0.98. What is the ratio of the Aid recevied (constant 2012 US$) of East Asia (all income levels) in 2000 to that in 2001?
Give a very brief answer. 1.03. What is the ratio of the Aid recevied (constant 2012 US$) in OECD members in 2000 to that in 2001?
Your answer should be compact. 1.36. What is the ratio of the Aid recevied (constant 2012 US$) in Central Europe in 2000 to that in 2002?
Make the answer very short. 1.42. What is the ratio of the Aid recevied (constant 2012 US$) of East Asia (all income levels) in 2000 to that in 2002?
Offer a terse response. 0.98. What is the ratio of the Aid recevied (constant 2012 US$) in OECD members in 2000 to that in 2002?
Provide a succinct answer. 1.5. What is the ratio of the Aid recevied (constant 2012 US$) in Central Europe in 2000 to that in 2003?
Provide a short and direct response. 1.15. What is the ratio of the Aid recevied (constant 2012 US$) in East Asia (all income levels) in 2000 to that in 2003?
Your answer should be compact. 1.52. What is the ratio of the Aid recevied (constant 2012 US$) in OECD members in 2000 to that in 2003?
Your answer should be very brief. 1.77. What is the ratio of the Aid recevied (constant 2012 US$) of Central Europe in 2000 to that in 2004?
Provide a short and direct response. 1.01. What is the ratio of the Aid recevied (constant 2012 US$) of East Asia (all income levels) in 2000 to that in 2004?
Make the answer very short. 0.88. What is the ratio of the Aid recevied (constant 2012 US$) in OECD members in 2000 to that in 2004?
Your answer should be very brief. 1.35. What is the ratio of the Aid recevied (constant 2012 US$) of Central Europe in 2001 to that in 2002?
Offer a terse response. 1.45. What is the ratio of the Aid recevied (constant 2012 US$) of East Asia (all income levels) in 2001 to that in 2002?
Your response must be concise. 0.95. What is the ratio of the Aid recevied (constant 2012 US$) of OECD members in 2001 to that in 2002?
Keep it short and to the point. 1.1. What is the ratio of the Aid recevied (constant 2012 US$) of Central Europe in 2001 to that in 2003?
Make the answer very short. 1.17. What is the ratio of the Aid recevied (constant 2012 US$) in East Asia (all income levels) in 2001 to that in 2003?
Your response must be concise. 1.48. What is the ratio of the Aid recevied (constant 2012 US$) of OECD members in 2001 to that in 2003?
Your answer should be very brief. 1.3. What is the ratio of the Aid recevied (constant 2012 US$) of Central Europe in 2001 to that in 2004?
Keep it short and to the point. 1.03. What is the ratio of the Aid recevied (constant 2012 US$) of East Asia (all income levels) in 2001 to that in 2004?
Your answer should be very brief. 0.85. What is the ratio of the Aid recevied (constant 2012 US$) in Central Europe in 2002 to that in 2003?
Provide a short and direct response. 0.81. What is the ratio of the Aid recevied (constant 2012 US$) in East Asia (all income levels) in 2002 to that in 2003?
Your response must be concise. 1.55. What is the ratio of the Aid recevied (constant 2012 US$) in OECD members in 2002 to that in 2003?
Your answer should be very brief. 1.18. What is the ratio of the Aid recevied (constant 2012 US$) of Central Europe in 2002 to that in 2004?
Provide a succinct answer. 0.71. What is the ratio of the Aid recevied (constant 2012 US$) of East Asia (all income levels) in 2002 to that in 2004?
Make the answer very short. 0.89. What is the ratio of the Aid recevied (constant 2012 US$) of OECD members in 2002 to that in 2004?
Make the answer very short. 0.9. What is the ratio of the Aid recevied (constant 2012 US$) in Central Europe in 2003 to that in 2004?
Make the answer very short. 0.88. What is the ratio of the Aid recevied (constant 2012 US$) of East Asia (all income levels) in 2003 to that in 2004?
Keep it short and to the point. 0.57. What is the ratio of the Aid recevied (constant 2012 US$) of OECD members in 2003 to that in 2004?
Your answer should be very brief. 0.76. What is the difference between the highest and the second highest Aid recevied (constant 2012 US$) of Central Europe?
Give a very brief answer. 9.83e+07. What is the difference between the highest and the second highest Aid recevied (constant 2012 US$) of East Asia (all income levels)?
Give a very brief answer. 1.35e+08. What is the difference between the highest and the second highest Aid recevied (constant 2012 US$) of OECD members?
Your answer should be compact. 1.90e+08. What is the difference between the highest and the lowest Aid recevied (constant 2012 US$) in Central Europe?
Give a very brief answer. 2.66e+09. What is the difference between the highest and the lowest Aid recevied (constant 2012 US$) in East Asia (all income levels)?
Keep it short and to the point. 1.24e+09. What is the difference between the highest and the lowest Aid recevied (constant 2012 US$) of OECD members?
Offer a very short reply. 2.04e+09. 